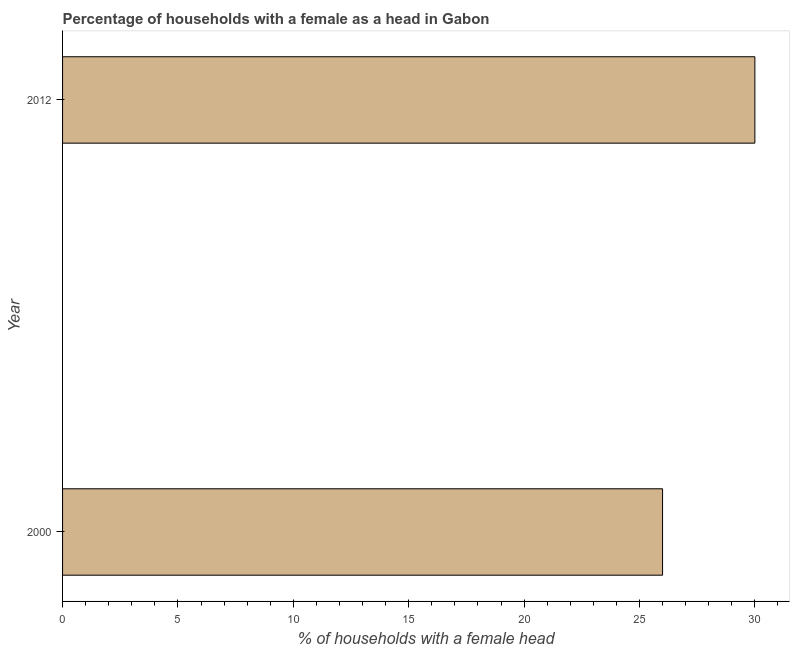Does the graph contain grids?
Your answer should be very brief. No. What is the title of the graph?
Your response must be concise. Percentage of households with a female as a head in Gabon. What is the label or title of the X-axis?
Your answer should be compact. % of households with a female head. What is the label or title of the Y-axis?
Your answer should be compact. Year. What is the number of female supervised households in 2012?
Your response must be concise. 30. In which year was the number of female supervised households maximum?
Your answer should be compact. 2012. In which year was the number of female supervised households minimum?
Provide a succinct answer. 2000. What is the sum of the number of female supervised households?
Your response must be concise. 56. What is the median number of female supervised households?
Give a very brief answer. 28. What is the ratio of the number of female supervised households in 2000 to that in 2012?
Give a very brief answer. 0.87. In how many years, is the number of female supervised households greater than the average number of female supervised households taken over all years?
Give a very brief answer. 1. How many bars are there?
Your answer should be compact. 2. Are all the bars in the graph horizontal?
Keep it short and to the point. Yes. What is the difference between two consecutive major ticks on the X-axis?
Make the answer very short. 5. What is the % of households with a female head of 2000?
Provide a short and direct response. 26. What is the ratio of the % of households with a female head in 2000 to that in 2012?
Your answer should be compact. 0.87. 